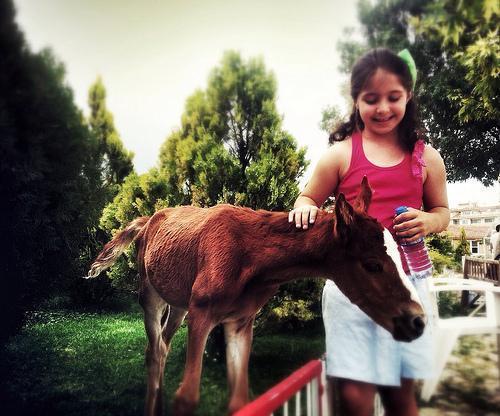How many horses are there in the picture?
Give a very brief answer. 1. 